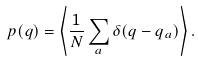<formula> <loc_0><loc_0><loc_500><loc_500>p ( q ) = \left \langle \frac { 1 } { N } \sum _ { a } \delta ( q - q _ { a } ) \right \rangle .</formula> 